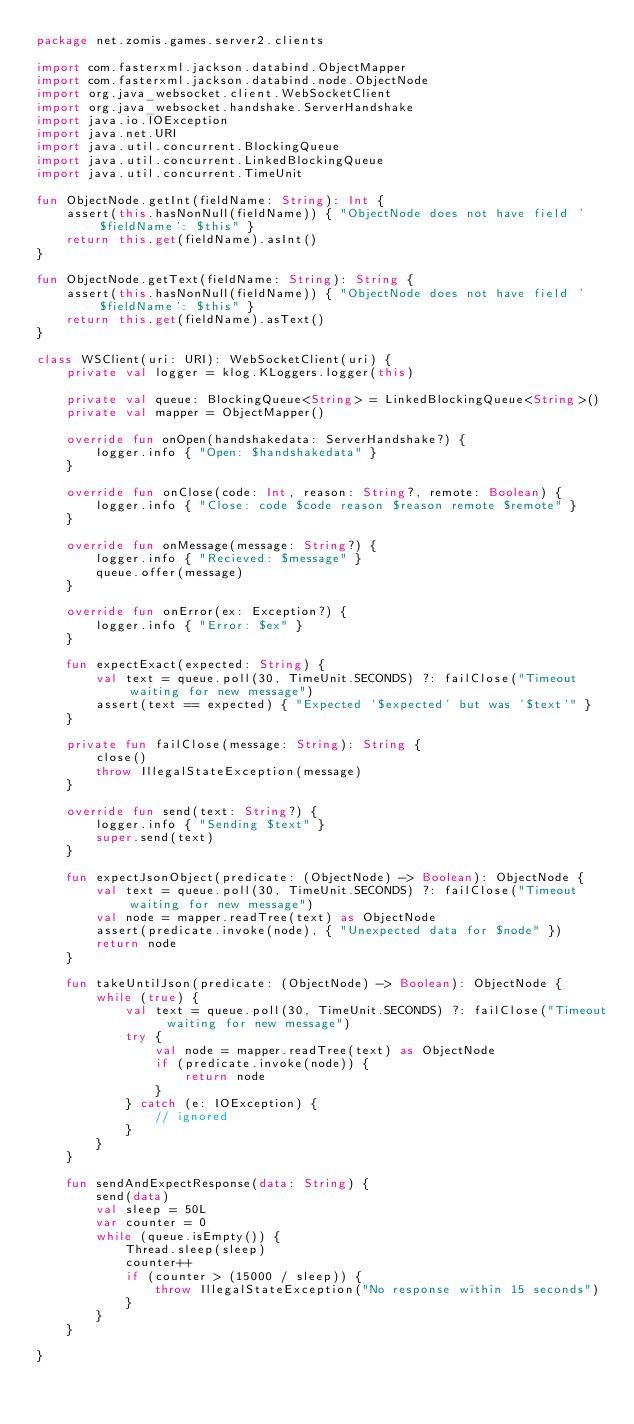Convert code to text. <code><loc_0><loc_0><loc_500><loc_500><_Kotlin_>package net.zomis.games.server2.clients

import com.fasterxml.jackson.databind.ObjectMapper
import com.fasterxml.jackson.databind.node.ObjectNode
import org.java_websocket.client.WebSocketClient
import org.java_websocket.handshake.ServerHandshake
import java.io.IOException
import java.net.URI
import java.util.concurrent.BlockingQueue
import java.util.concurrent.LinkedBlockingQueue
import java.util.concurrent.TimeUnit

fun ObjectNode.getInt(fieldName: String): Int {
    assert(this.hasNonNull(fieldName)) { "ObjectNode does not have field '$fieldName': $this" }
    return this.get(fieldName).asInt()
}

fun ObjectNode.getText(fieldName: String): String {
    assert(this.hasNonNull(fieldName)) { "ObjectNode does not have field '$fieldName': $this" }
    return this.get(fieldName).asText()
}

class WSClient(uri: URI): WebSocketClient(uri) {
    private val logger = klog.KLoggers.logger(this)

    private val queue: BlockingQueue<String> = LinkedBlockingQueue<String>()
    private val mapper = ObjectMapper()

    override fun onOpen(handshakedata: ServerHandshake?) {
        logger.info { "Open: $handshakedata" }
    }

    override fun onClose(code: Int, reason: String?, remote: Boolean) {
        logger.info { "Close: code $code reason $reason remote $remote" }
    }

    override fun onMessage(message: String?) {
        logger.info { "Recieved: $message" }
        queue.offer(message)
    }

    override fun onError(ex: Exception?) {
        logger.info { "Error: $ex" }
    }

    fun expectExact(expected: String) {
        val text = queue.poll(30, TimeUnit.SECONDS) ?: failClose("Timeout waiting for new message")
        assert(text == expected) { "Expected '$expected' but was '$text'" }
    }

    private fun failClose(message: String): String {
        close()
        throw IllegalStateException(message)
    }

    override fun send(text: String?) {
        logger.info { "Sending $text" }
        super.send(text)
    }

    fun expectJsonObject(predicate: (ObjectNode) -> Boolean): ObjectNode {
        val text = queue.poll(30, TimeUnit.SECONDS) ?: failClose("Timeout waiting for new message")
        val node = mapper.readTree(text) as ObjectNode
        assert(predicate.invoke(node), { "Unexpected data for $node" })
        return node
    }

    fun takeUntilJson(predicate: (ObjectNode) -> Boolean): ObjectNode {
        while (true) {
            val text = queue.poll(30, TimeUnit.SECONDS) ?: failClose("Timeout waiting for new message")
            try {
                val node = mapper.readTree(text) as ObjectNode
                if (predicate.invoke(node)) {
                    return node
                }
            } catch (e: IOException) {
                // ignored
            }
        }
    }

    fun sendAndExpectResponse(data: String) {
        send(data)
        val sleep = 50L
        var counter = 0
        while (queue.isEmpty()) {
            Thread.sleep(sleep)
            counter++
            if (counter > (15000 / sleep)) {
                throw IllegalStateException("No response within 15 seconds")
            }
        }
    }

}
</code> 